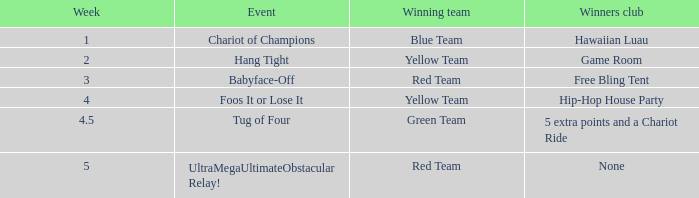How many weeks have a Winning team of yellow team, and an Event of foos it or lose it? 4.0. Could you parse the entire table? {'header': ['Week', 'Event', 'Winning team', 'Winners club'], 'rows': [['1', 'Chariot of Champions', 'Blue Team', 'Hawaiian Luau'], ['2', 'Hang Tight', 'Yellow Team', 'Game Room'], ['3', 'Babyface-Off', 'Red Team', 'Free Bling Tent'], ['4', 'Foos It or Lose It', 'Yellow Team', 'Hip-Hop House Party'], ['4.5', 'Tug of Four', 'Green Team', '5 extra points and a Chariot Ride'], ['5', 'UltraMegaUltimateObstacular Relay!', 'Red Team', 'None']]} 